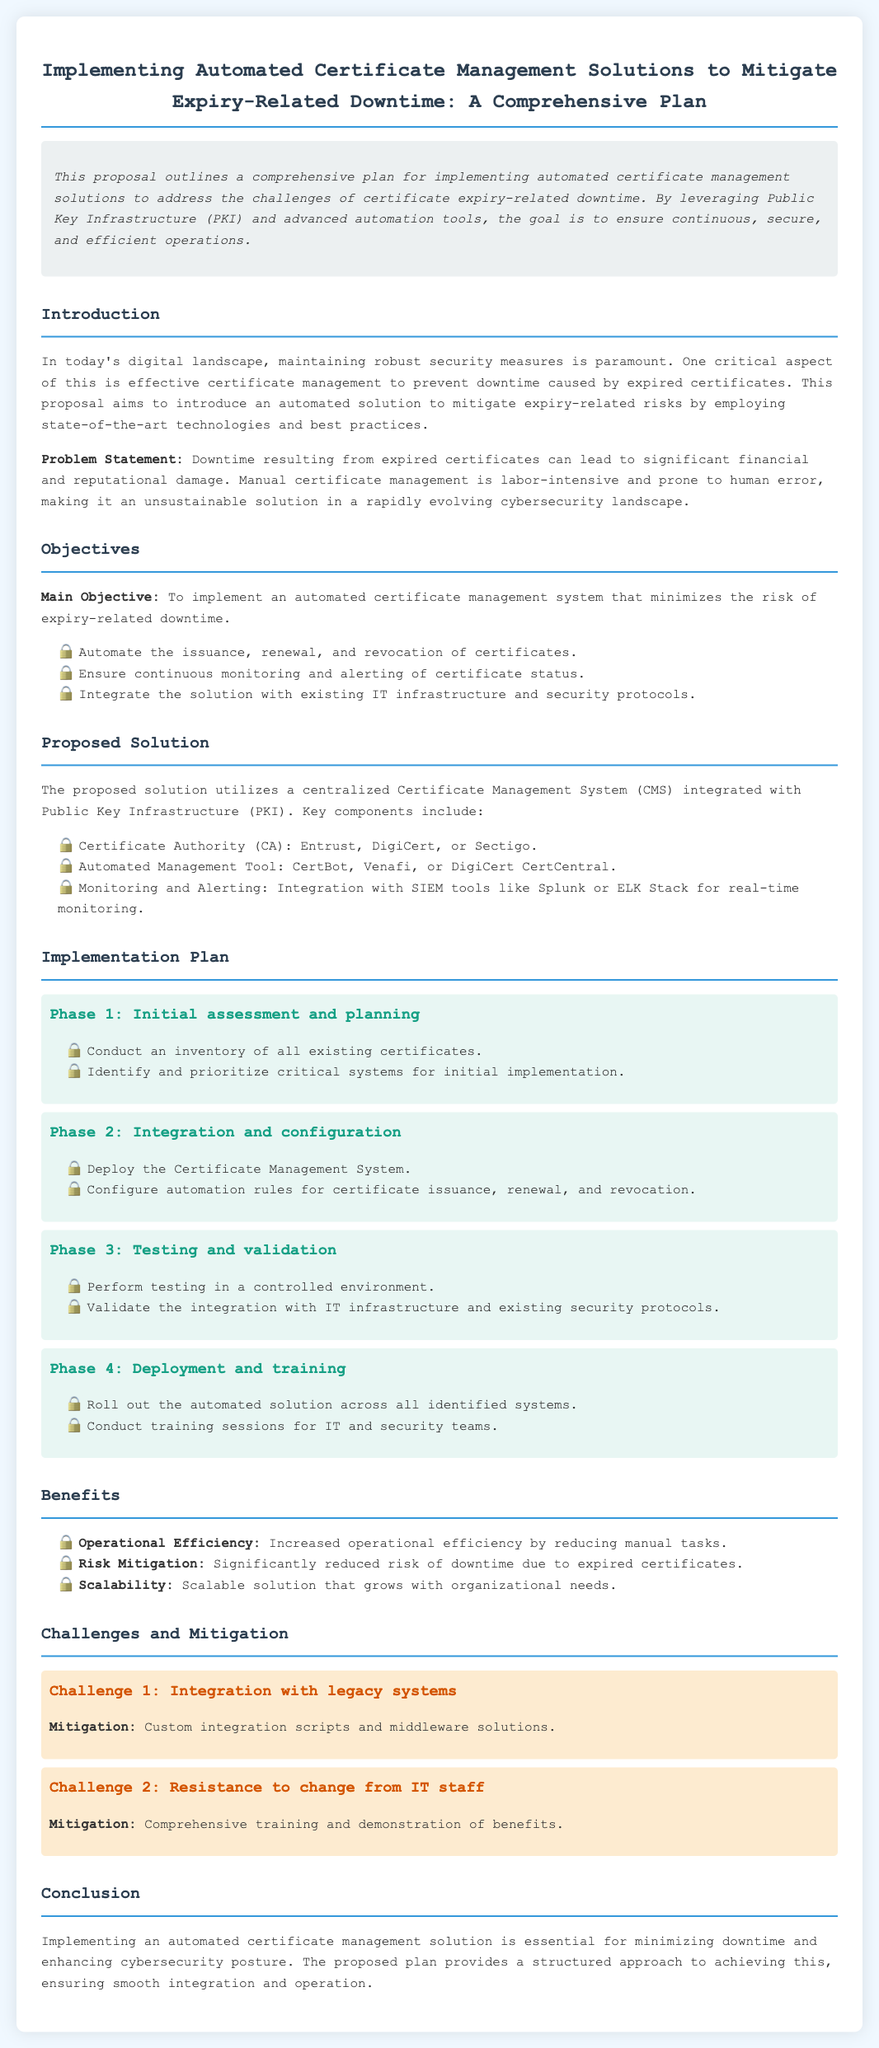what is the main objective of the proposal? The main objective is to implement an automated certificate management system that minimizes the risk of expiry-related downtime.
Answer: minimize the risk of expiry-related downtime what are the key components of the proposed solution? The key components listed in the document include the Certificate Authority, Automated Management Tool, and Monitoring and Alerting.
Answer: Certificate Authority, Automated Management Tool, Monitoring and Alerting which automated management tools are mentioned in the proposal? The proposal mentions CertBot, Venafi, and DigiCert CertCentral as the automated management tools.
Answer: CertBot, Venafi, DigiCert CertCentral what is the first phase of the implementation plan? The first phase involves conducting an inventory of all existing certificates and identifying critical systems for initial implementation.
Answer: Initial assessment and planning what is one benefit of the proposed automated certificate management solution? The document states that one benefit is increased operational efficiency by reducing manual tasks.
Answer: Increased operational efficiency how many challenges are addressed in the proposal? The proposal addresses two challenges regarding integration and resistance to change from IT staff.
Answer: two what solution is proposed to mitigate integration challenges with legacy systems? The proposed solution for integration challenges is to use custom integration scripts and middleware solutions.
Answer: Custom integration scripts and middleware solutions what is the role of the Certificate Authority in the proposed solution? The Certificate Authority is responsible for issuing the certificates as part of the automated certificate management process.
Answer: Issuing certificates what are the last two phases of the implementation plan? The last two phases include Deployment and Training.
Answer: Deployment and Training 